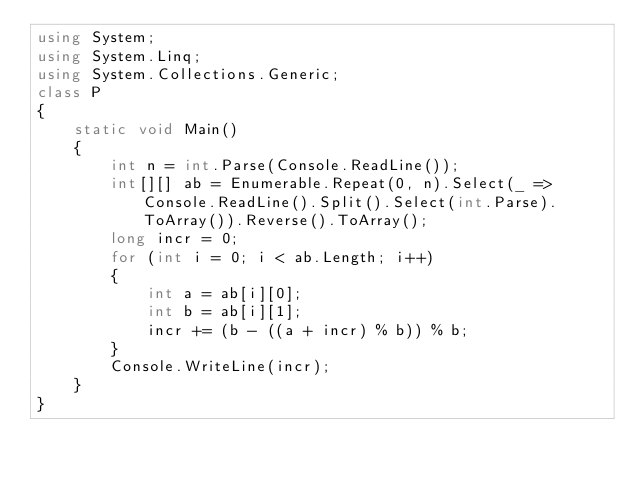<code> <loc_0><loc_0><loc_500><loc_500><_C#_>using System;
using System.Linq;
using System.Collections.Generic;
class P
{
    static void Main()
    {
        int n = int.Parse(Console.ReadLine());
        int[][] ab = Enumerable.Repeat(0, n).Select(_ => Console.ReadLine().Split().Select(int.Parse).ToArray()).Reverse().ToArray();
        long incr = 0;
        for (int i = 0; i < ab.Length; i++)
        {
            int a = ab[i][0];
            int b = ab[i][1];
            incr += (b - ((a + incr) % b)) % b;
        }
        Console.WriteLine(incr);
    }
}</code> 